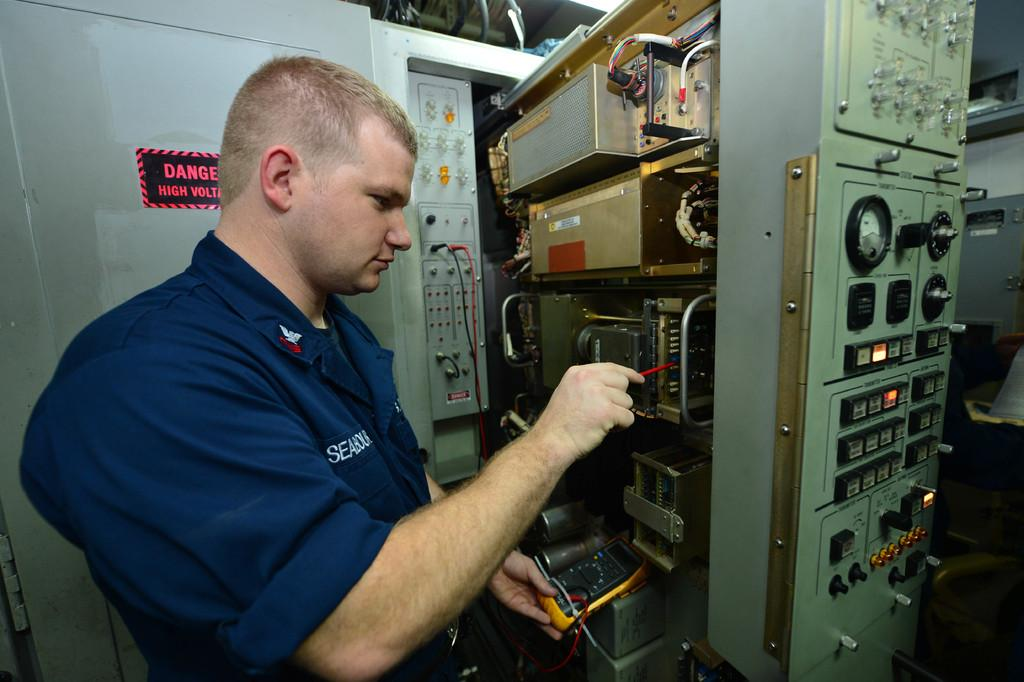Who is present in the image? There is a person in the image. What is the person wearing? The person is wearing a blue shirt. What can be seen on the right side of the image? There is a machine on the right side of the image. What is the person doing in the image? The person is fixing something in the image. What type of lip can be seen on the machine in the image? There is no lip present on the machine in the image. 